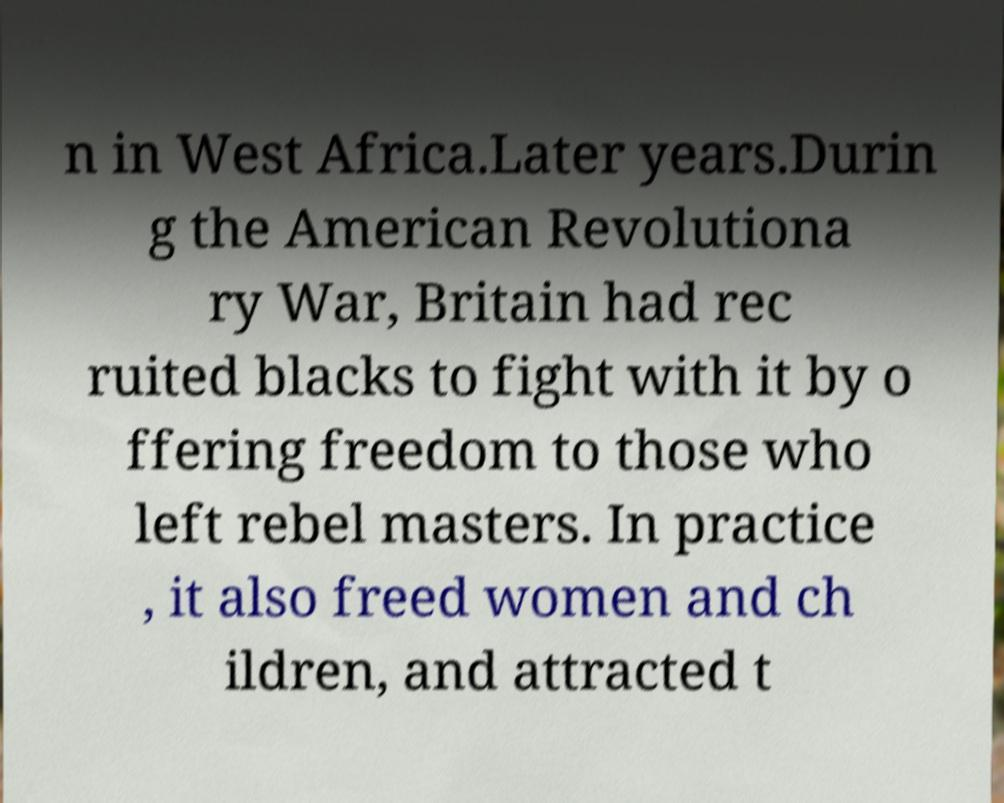Please read and relay the text visible in this image. What does it say? n in West Africa.Later years.Durin g the American Revolutiona ry War, Britain had rec ruited blacks to fight with it by o ffering freedom to those who left rebel masters. In practice , it also freed women and ch ildren, and attracted t 